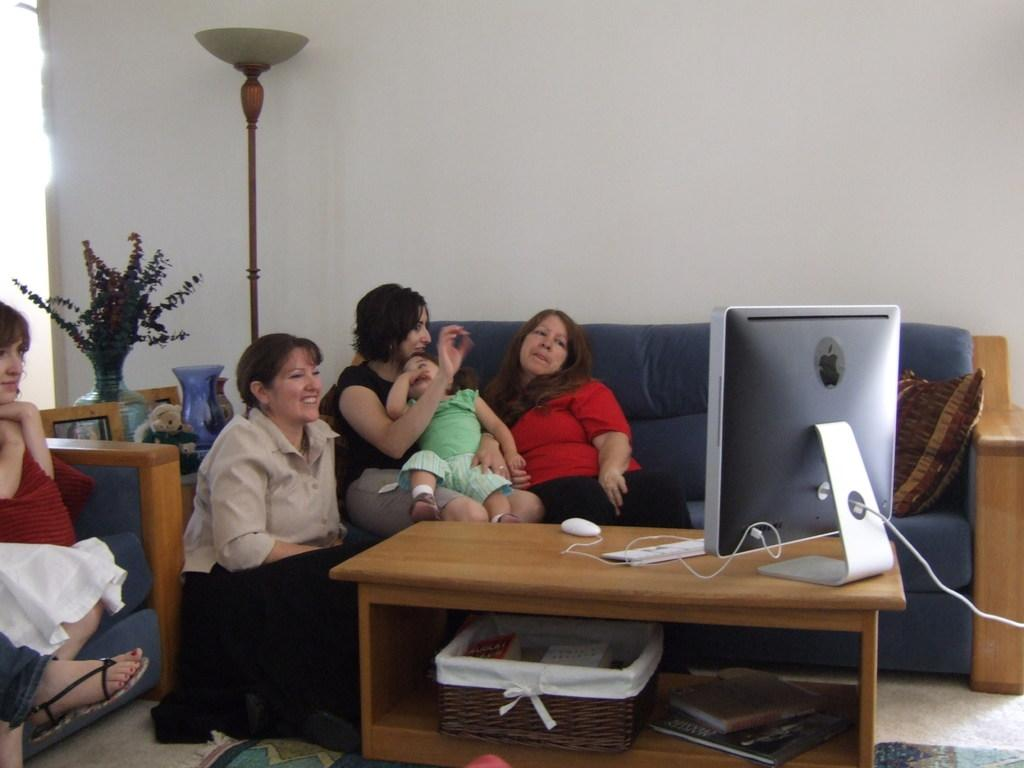How many people are in the image? There is a group of people in the image. What are the people doing in the image? The people are sitting in the image. What are the people looking at in the image? The people are looking at a Mac desktop in the image. Where is the Mac desktop located in the image? The Mac desktop is on a table in the image. What type of addition problem can be seen on the Mac desktop in the image? There is no addition problem visible on the Mac desktop in the image. What feeling is the group of people expressing in the image? The image does not convey any specific feelings or emotions of the people. 